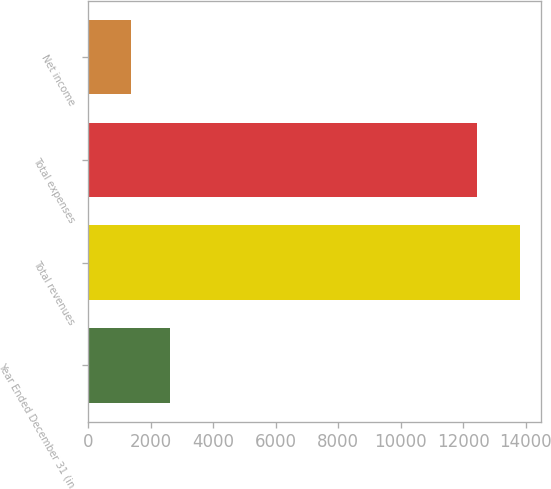<chart> <loc_0><loc_0><loc_500><loc_500><bar_chart><fcel>Year Ended December 31 (in<fcel>Total revenues<fcel>Total expenses<fcel>Net income<nl><fcel>2609.6<fcel>13802<fcel>12436<fcel>1366<nl></chart> 